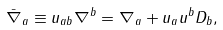<formula> <loc_0><loc_0><loc_500><loc_500>\bar { \nabla } _ { a } \equiv u _ { a b } \nabla ^ { b } = \nabla _ { a } + u _ { a } u ^ { b } D _ { b } ,</formula> 